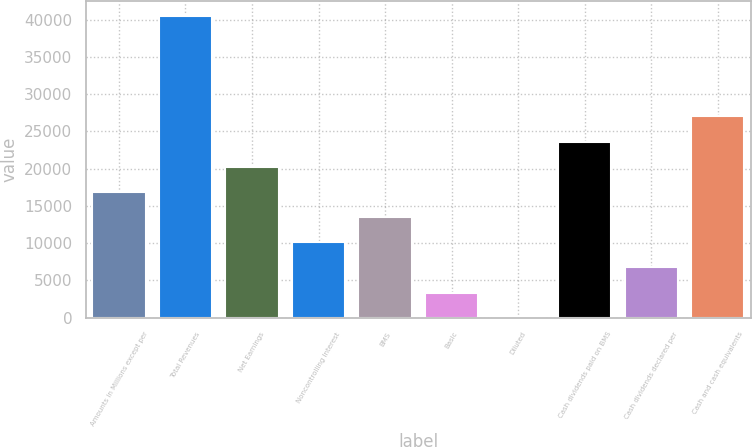Convert chart to OTSL. <chart><loc_0><loc_0><loc_500><loc_500><bar_chart><fcel>Amounts in Millions except per<fcel>Total Revenues<fcel>Net Earnings<fcel>Noncontrolling Interest<fcel>BMS<fcel>Basic<fcel>Diluted<fcel>Cash dividends paid on BMS<fcel>Cash dividends declared per<fcel>Cash and cash equivalents<nl><fcel>16875.1<fcel>40498.6<fcel>20249.9<fcel>10125.5<fcel>13500.3<fcel>3375.98<fcel>1.2<fcel>23624.7<fcel>6750.76<fcel>26999.4<nl></chart> 